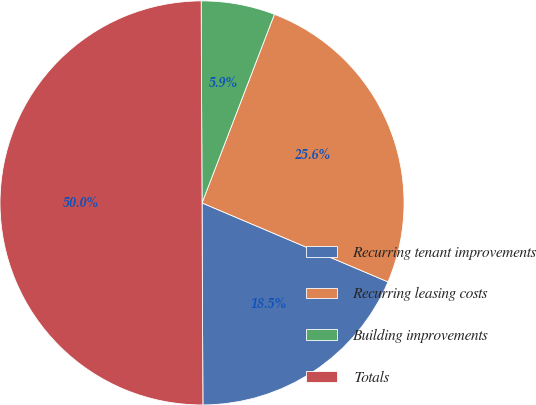<chart> <loc_0><loc_0><loc_500><loc_500><pie_chart><fcel>Recurring tenant improvements<fcel>Recurring leasing costs<fcel>Building improvements<fcel>Totals<nl><fcel>18.54%<fcel>25.56%<fcel>5.9%<fcel>50.0%<nl></chart> 